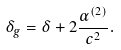<formula> <loc_0><loc_0><loc_500><loc_500>\delta _ { g } = \delta + 2 \frac { \alpha ^ { ( 2 ) } } { c ^ { 2 } } .</formula> 